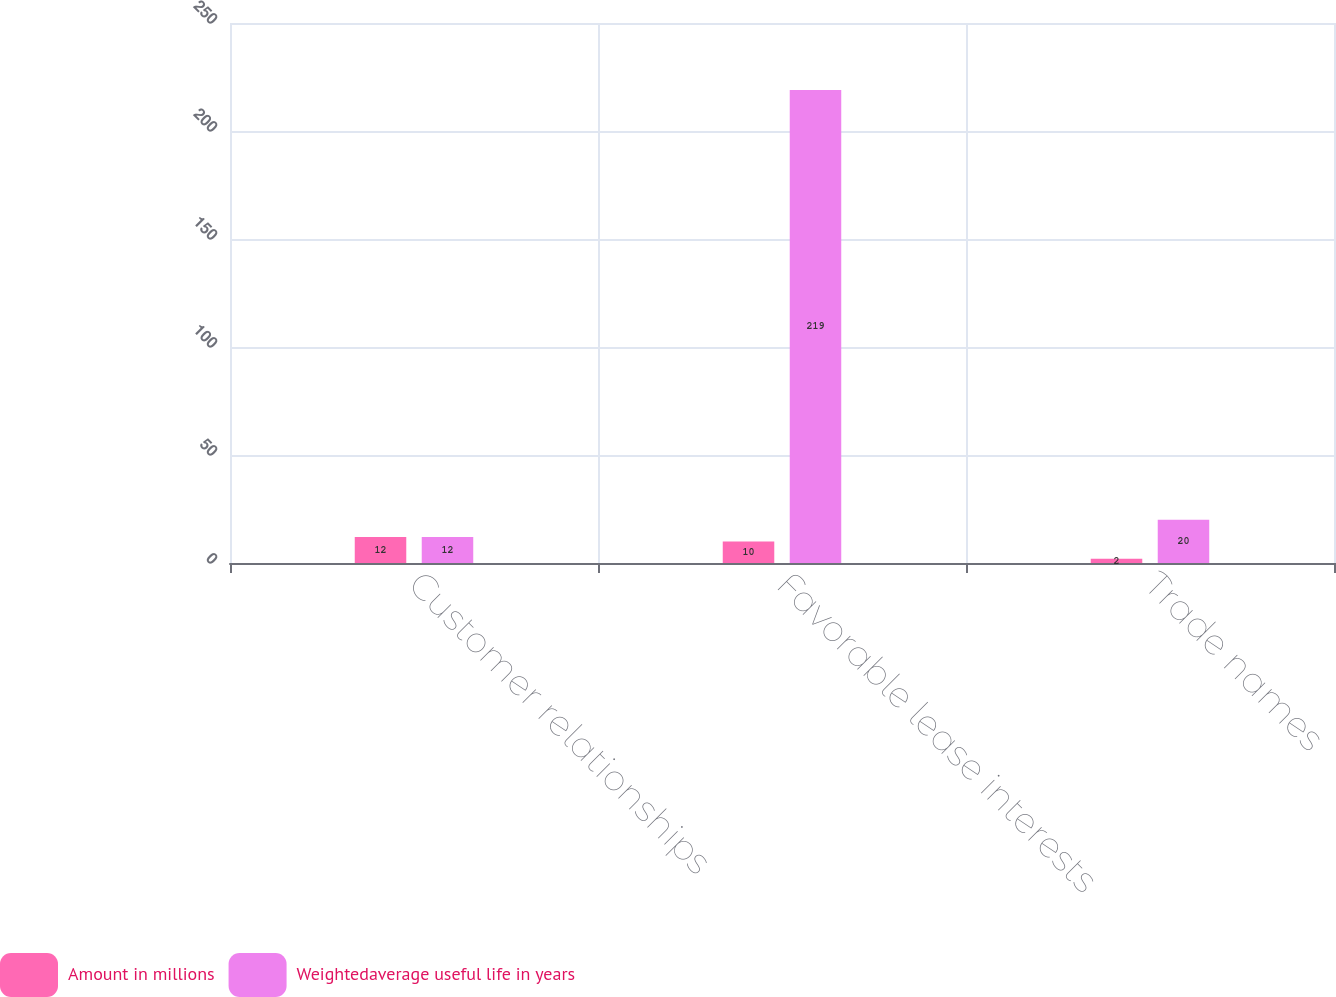<chart> <loc_0><loc_0><loc_500><loc_500><stacked_bar_chart><ecel><fcel>Customer relationships<fcel>Favorable lease interests<fcel>Trade names<nl><fcel>Amount in millions<fcel>12<fcel>10<fcel>2<nl><fcel>Weightedaverage useful life in years<fcel>12<fcel>219<fcel>20<nl></chart> 